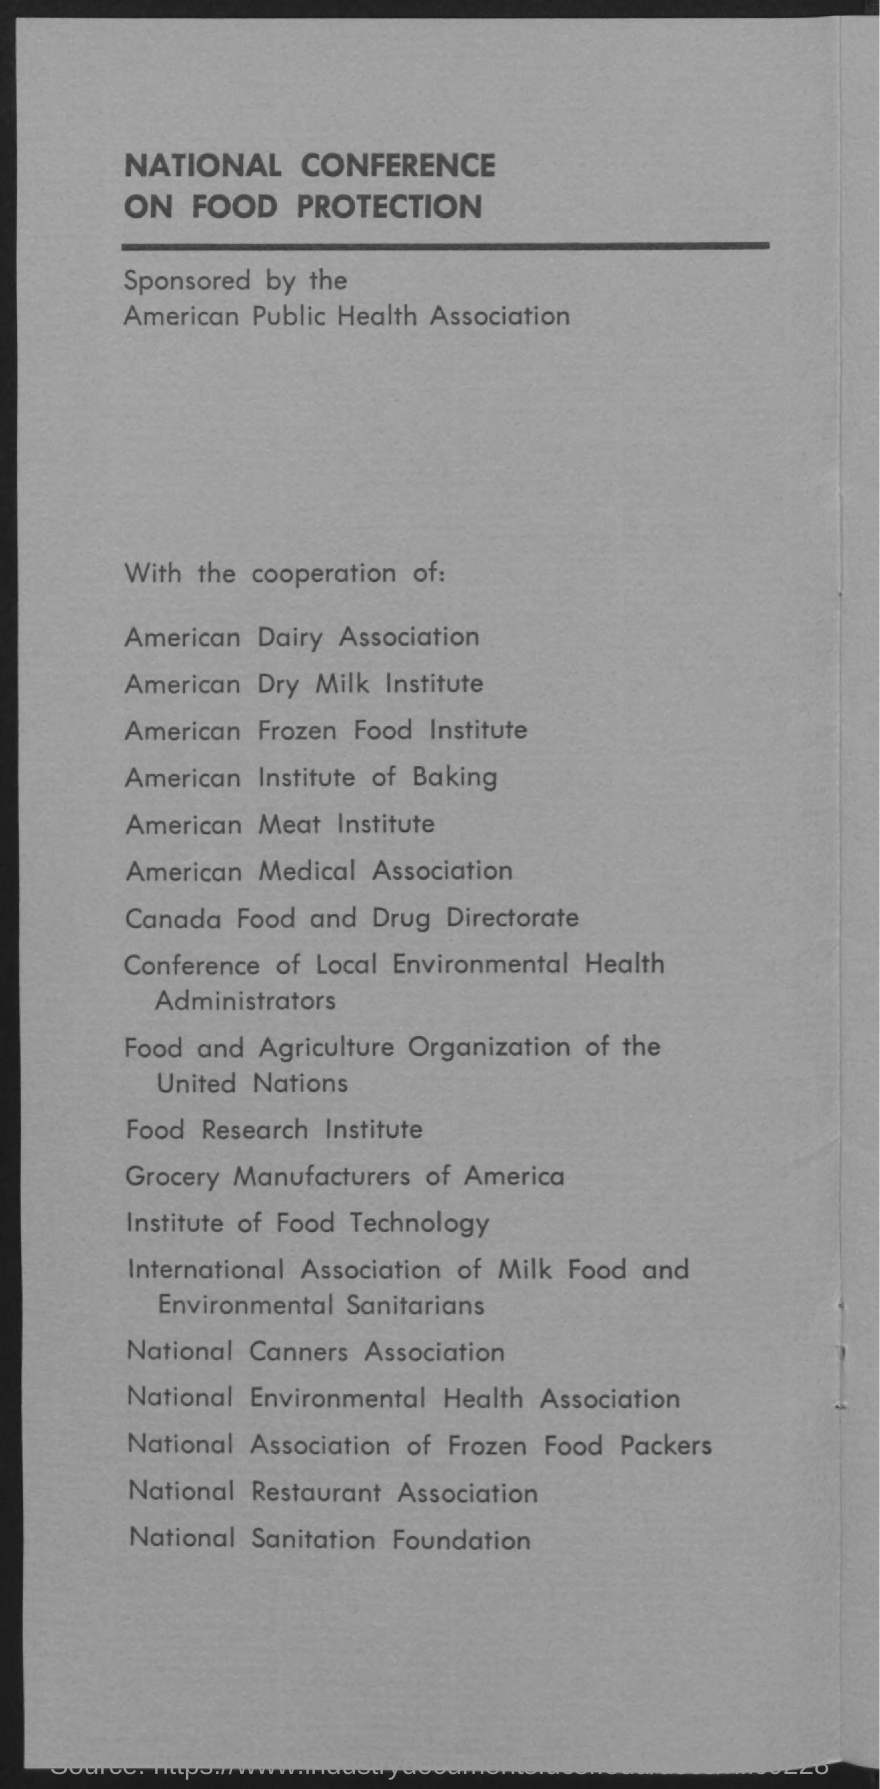What is national conference on?
Provide a succinct answer. FOOD PROTECTION. Who is sponsoring national conference on food protection?
Provide a short and direct response. American Public Health Association. 